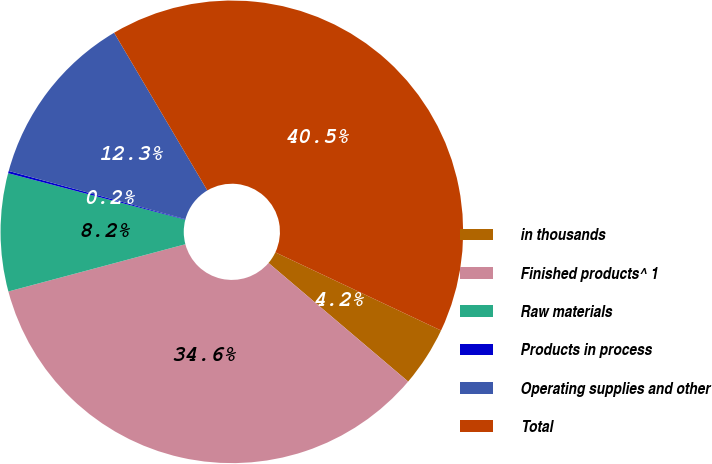<chart> <loc_0><loc_0><loc_500><loc_500><pie_chart><fcel>in thousands<fcel>Finished products^ 1<fcel>Raw materials<fcel>Products in process<fcel>Operating supplies and other<fcel>Total<nl><fcel>4.19%<fcel>34.64%<fcel>8.23%<fcel>0.16%<fcel>12.26%<fcel>40.51%<nl></chart> 